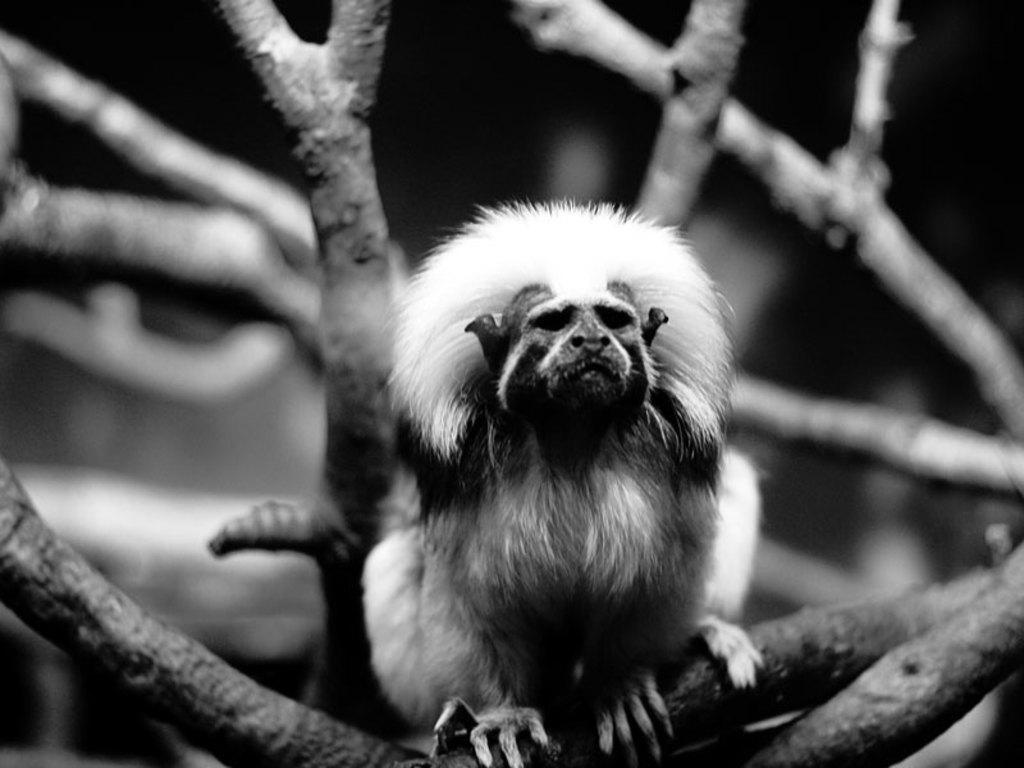In one or two sentences, can you explain what this image depicts? In this image I can see number of branches and in the front I can see one monkey on one branch. I can also see this image is black and white in colour. 